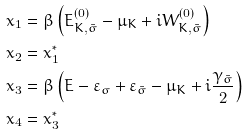Convert formula to latex. <formula><loc_0><loc_0><loc_500><loc_500>x _ { 1 } & = \beta \left ( E _ { K , \bar { \sigma } } ^ { ( 0 ) } - \mu _ { K } + i W _ { K , \bar { \sigma } } ^ { ( 0 ) } \right ) \\ x _ { 2 } & = x _ { 1 } ^ { * } \\ x _ { 3 } & = \beta \left ( E - \varepsilon _ { \sigma } + \varepsilon _ { \bar { \sigma } } - \mu _ { K } + i \frac { \gamma _ { \bar { \sigma } } } { 2 } \right ) \\ x _ { 4 } & = x _ { 3 } ^ { * }</formula> 